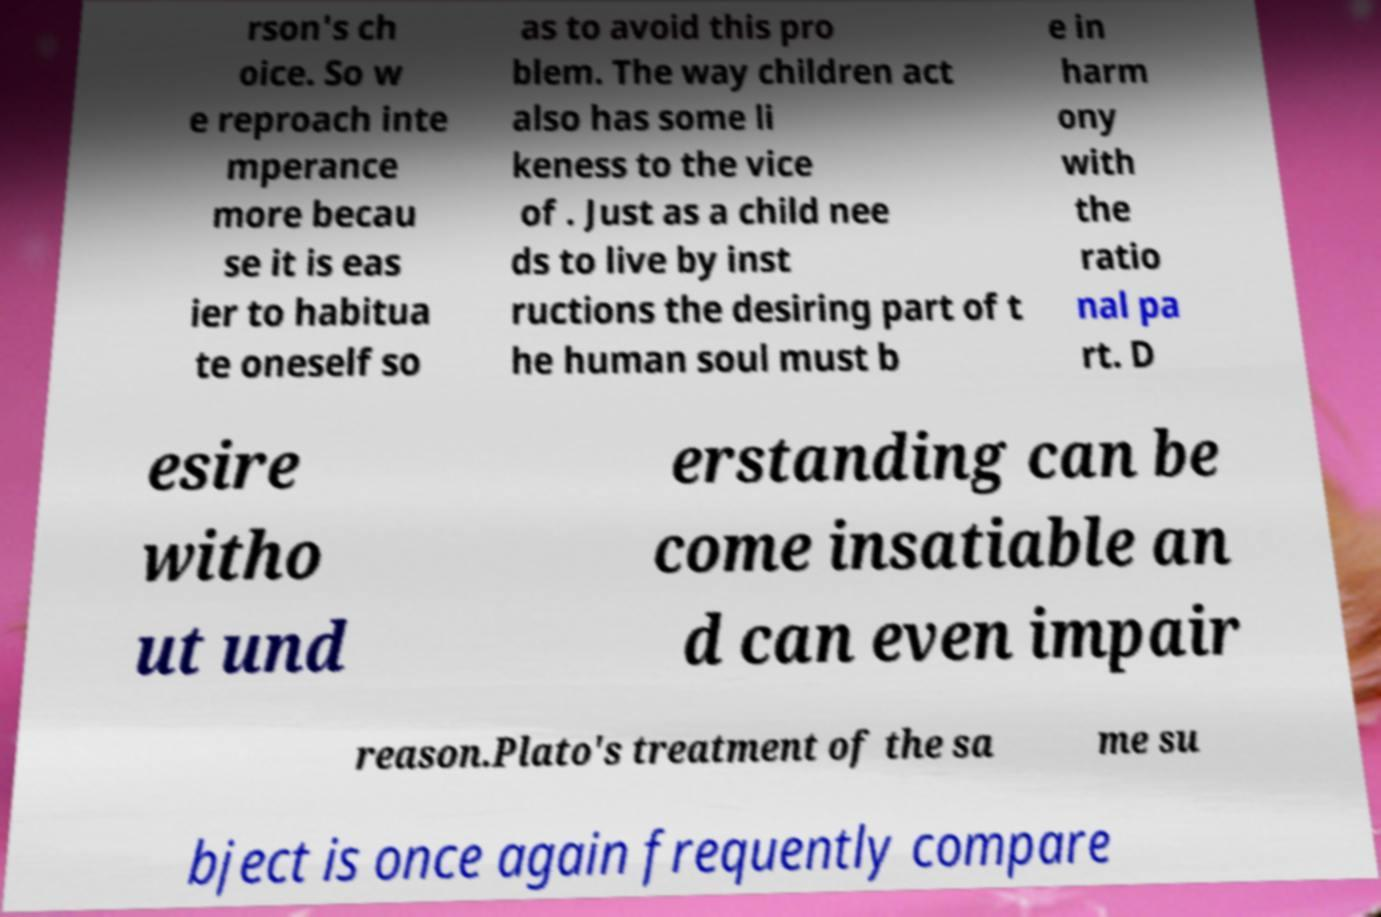Can you accurately transcribe the text from the provided image for me? rson's ch oice. So w e reproach inte mperance more becau se it is eas ier to habitua te oneself so as to avoid this pro blem. The way children act also has some li keness to the vice of . Just as a child nee ds to live by inst ructions the desiring part of t he human soul must b e in harm ony with the ratio nal pa rt. D esire witho ut und erstanding can be come insatiable an d can even impair reason.Plato's treatment of the sa me su bject is once again frequently compare 